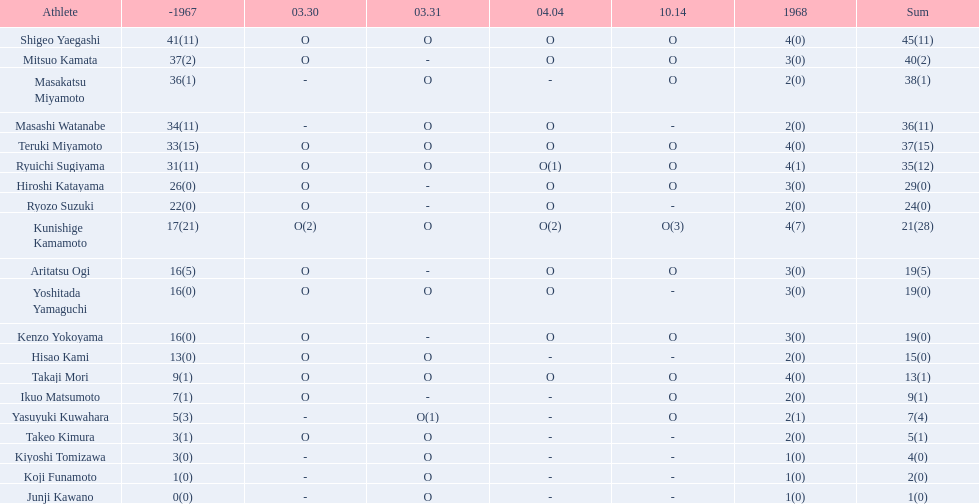How many players made an appearance that year? 20. 